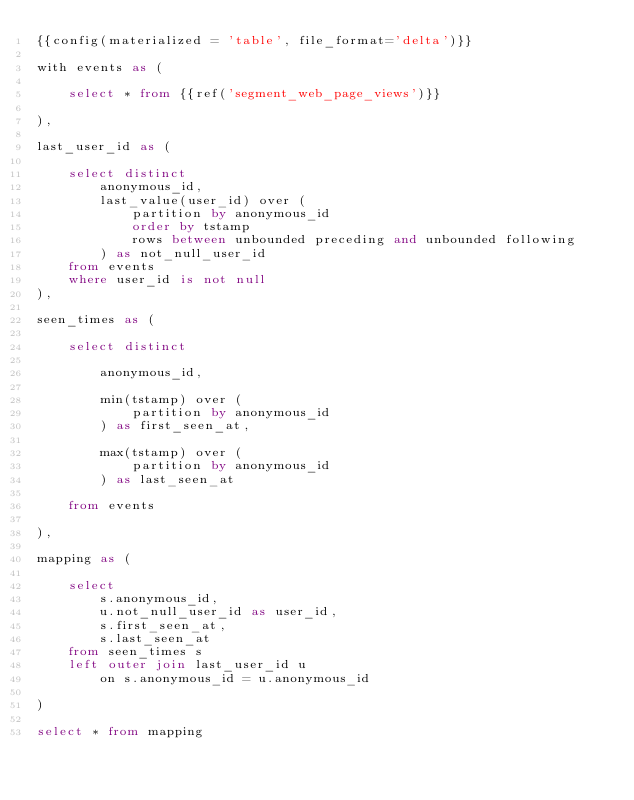<code> <loc_0><loc_0><loc_500><loc_500><_SQL_>{{config(materialized = 'table', file_format='delta')}}

with events as (

    select * from {{ref('segment_web_page_views')}}

),

last_user_id as (

    select distinct 
        anonymous_id,
        last_value(user_id) over (
            partition by anonymous_id
            order by tstamp
            rows between unbounded preceding and unbounded following
        ) as not_null_user_id
    from events
    where user_id is not null
),

seen_times as (

    select distinct

        anonymous_id,

        min(tstamp) over (
            partition by anonymous_id
        ) as first_seen_at,

        max(tstamp) over (
            partition by anonymous_id
        ) as last_seen_at

    from events

),

mapping as (

    select 
        s.anonymous_id,
        u.not_null_user_id as user_id,
        s.first_seen_at,
        s.last_seen_at
    from seen_times s
    left outer join last_user_id u 
        on s.anonymous_id = u.anonymous_id

)

select * from mapping
</code> 